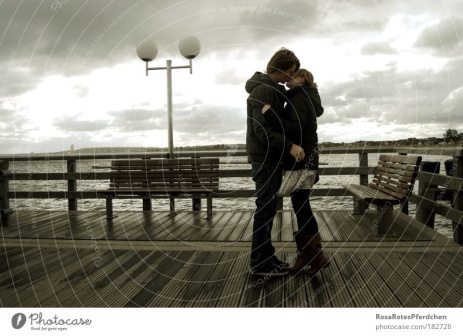What do you think this couple is discussing? They might be discussing important plans for their future, perhaps planning a new chapter in their lives together. The depth of their conversation is mirrored by the overcast sky, adding a sense of seriousness and thoughtfulness to their dialogue. Could they be recalling a significant memory? It's quite possible that they are recalling a significant memory, perhaps the first time they met or an unforgettable moment from their past. Such locations often hold sentimental value, making them perfect places to revisit cherished memories. Imagine they heard some interesting news right before this moment. If they had heard some interesting news, it might be contributing to the tenderness of their embrace. Maybe they've just found out they're expecting a child or received some exciting news about a future opportunity. This could be a moment of taking it all in and sharing their happiness or anxieties with each other. What if this pier has a mysterious secret? Imagine this pier has a mysterious secret, something only known by a few, that this couple is just starting to uncover. Perhaps there's a legend that on foggy days, the spirits of long-lost sailors emerge from the waters, whispering secrets of the ocean to those who listen closely. Maybe this couple is drawn to the pier by an inexplicable feeling, entangling their fate with the enigmatic history of the place. Their embrace might be a form of protection and reassurance as they stand on the threshold of unraveling this ancient mystery. 